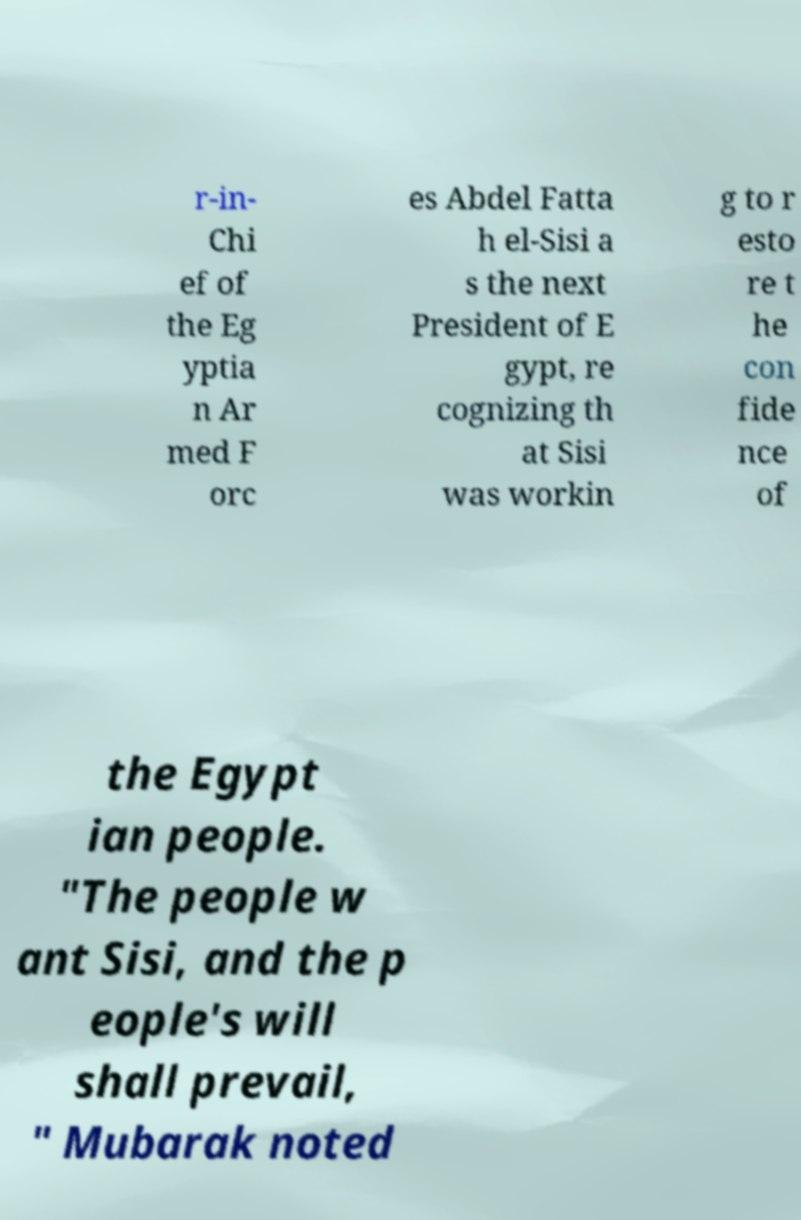There's text embedded in this image that I need extracted. Can you transcribe it verbatim? r-in- Chi ef of the Eg yptia n Ar med F orc es Abdel Fatta h el-Sisi a s the next President of E gypt, re cognizing th at Sisi was workin g to r esto re t he con fide nce of the Egypt ian people. "The people w ant Sisi, and the p eople's will shall prevail, " Mubarak noted 